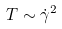Convert formula to latex. <formula><loc_0><loc_0><loc_500><loc_500>T \sim \dot { \gamma } ^ { 2 }</formula> 